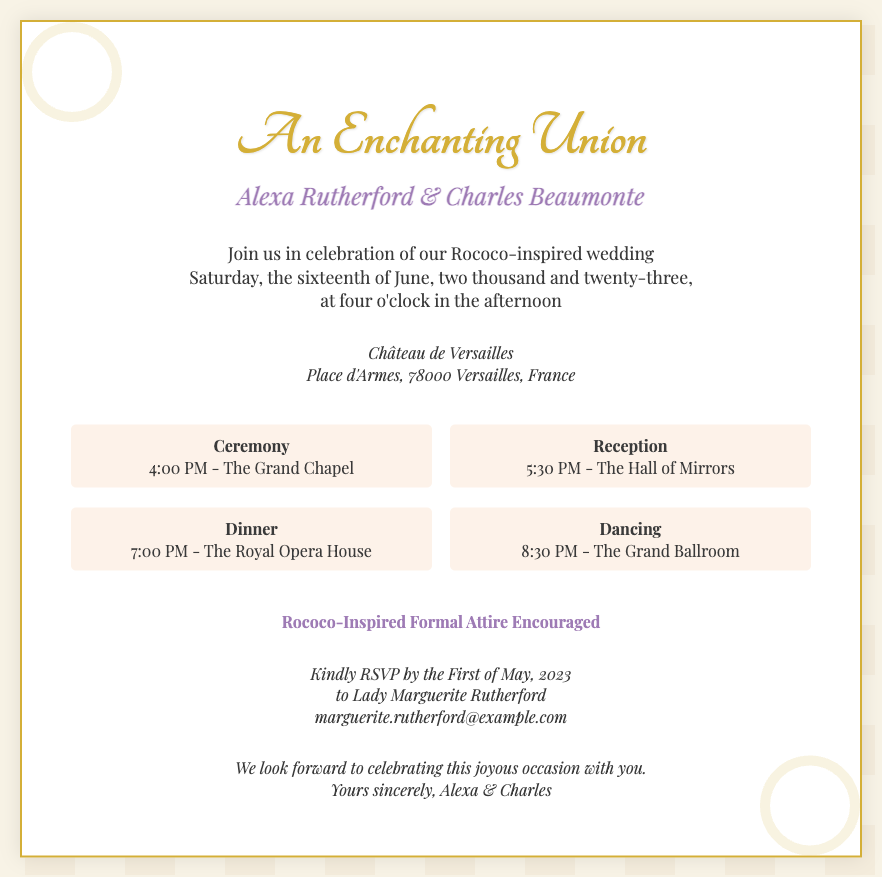What is the full name of the bride? The full name of the bride is given in the invitation as "Alexa Rutherford."
Answer: Alexa Rutherford What is the venue for the wedding? The venue is specified in the document as "Château de Versailles."
Answer: Château de Versailles On which date is the wedding scheduled? The wedding date is stated in the document as "June sixteenth, two thousand and twenty-three."
Answer: June sixteenth, two thousand and twenty-three What time does the ceremony begin? The ceremony start time is given in the schedule section as "4:00 PM."
Answer: 4:00 PM What type of attire is encouraged for the guests? The invitation mentions the type of attire that is "Rococo-Inspired Formal Attire."
Answer: Rococo-Inspired Formal Attire How many events are listed in the schedule? The schedule includes four distinct events, as indicated in the document.
Answer: Four To whom should guests RSVP? The document specifies that guests should RSVP to "Lady Marguerite Rutherford."
Answer: Lady Marguerite Rutherford What is the closing phrase of the invitation? The closing phrase expresses the couple's anticipation to celebrate, stated as "We look forward to celebrating this joyous occasion with you."
Answer: We look forward to celebrating this joyous occasion with you 